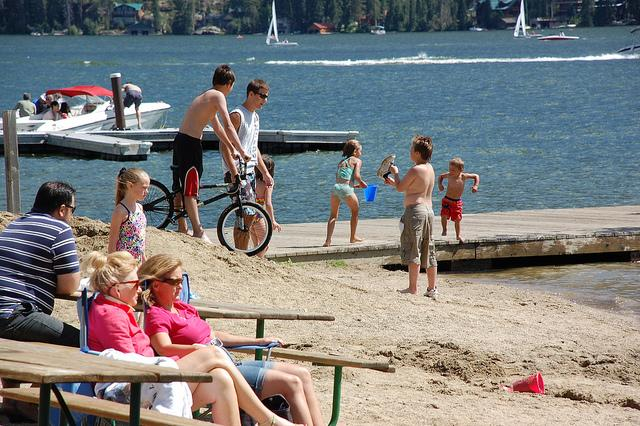Why is the boy holding up his shoe? sandy 